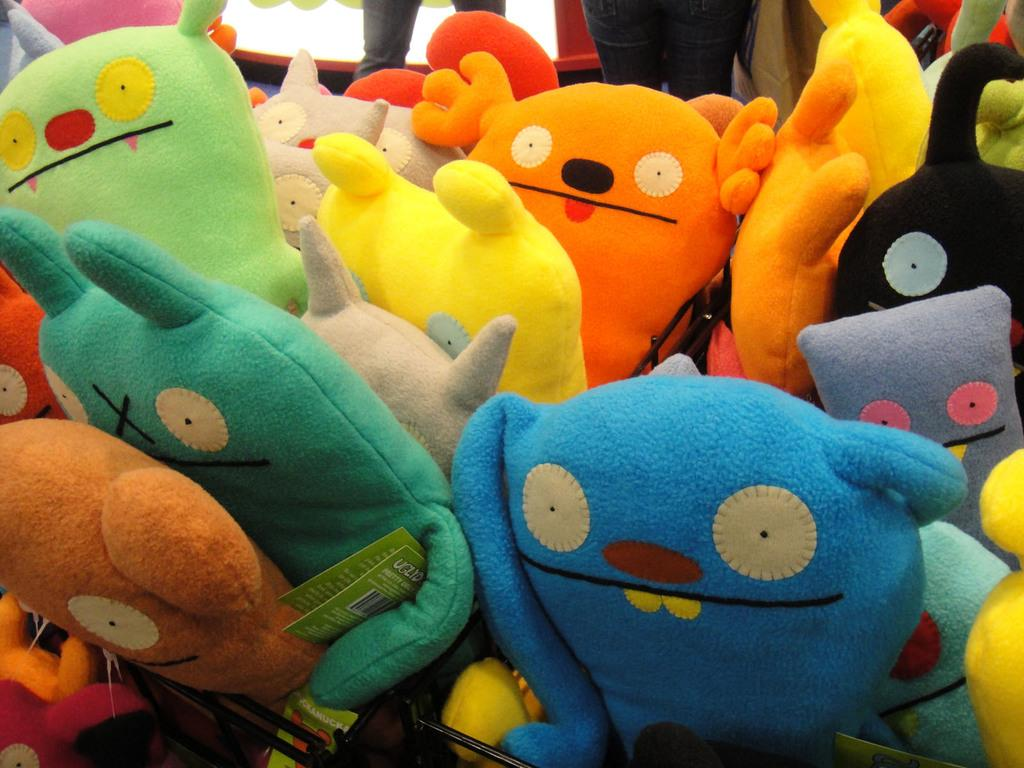Where was the image taken? The image is taken indoors. What can be found in the basket in the image? There are many toys in the basket. How do the toys in the basket differ from each other? The toys are different in colors. What can be seen in the background of the image? There are people standing in the background. What position are the people in the background? The people are on the floor. What direction is the tooth facing in the image? There is no tooth present in the image. Is the veil being used by anyone in the image? There is no veil present in the image. 